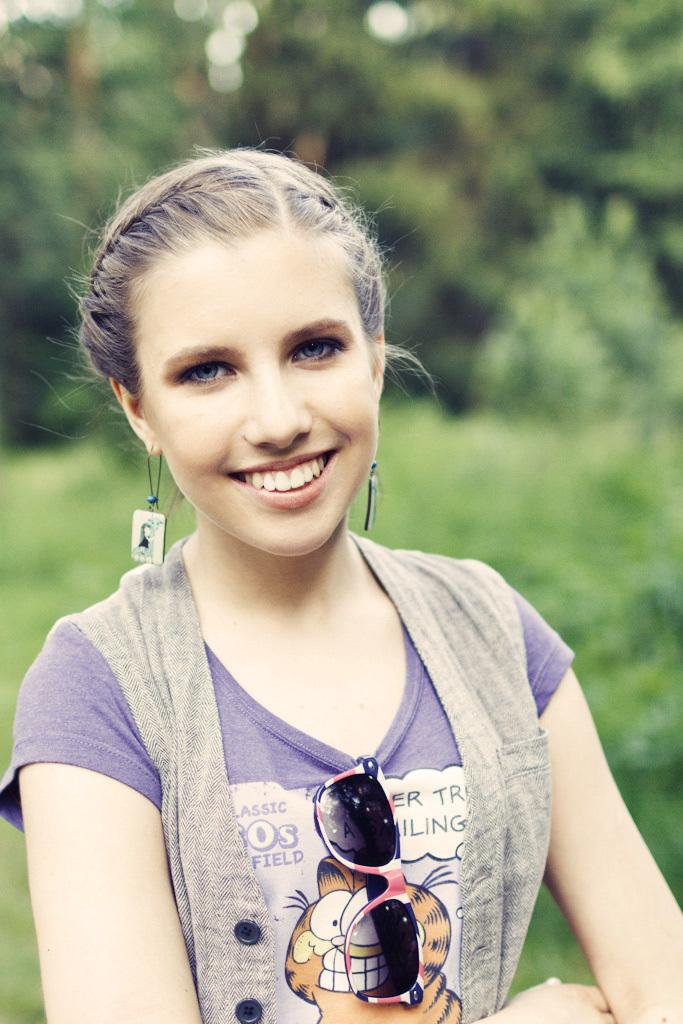What is the main subject of the image? There is a person standing in the image. Can you describe the person's clothing? The person is wearing a gray and purple color dress. What can be seen in the background of the image? There are trees in the background of the image. What is the color of the trees? The trees are green in color. Who is the owner of the peace symbol in the image? There is no peace symbol present in the image. What word is written on the person's dress in the image? The facts provided do not mention any words on the person's dress. 